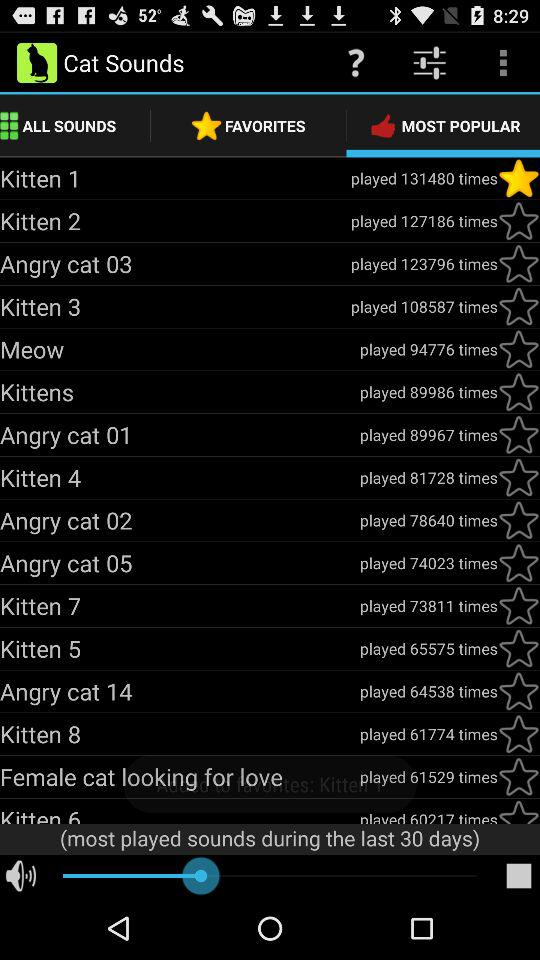Which tab is currently selected? The currently selected tab is "MOST POPULAR". 